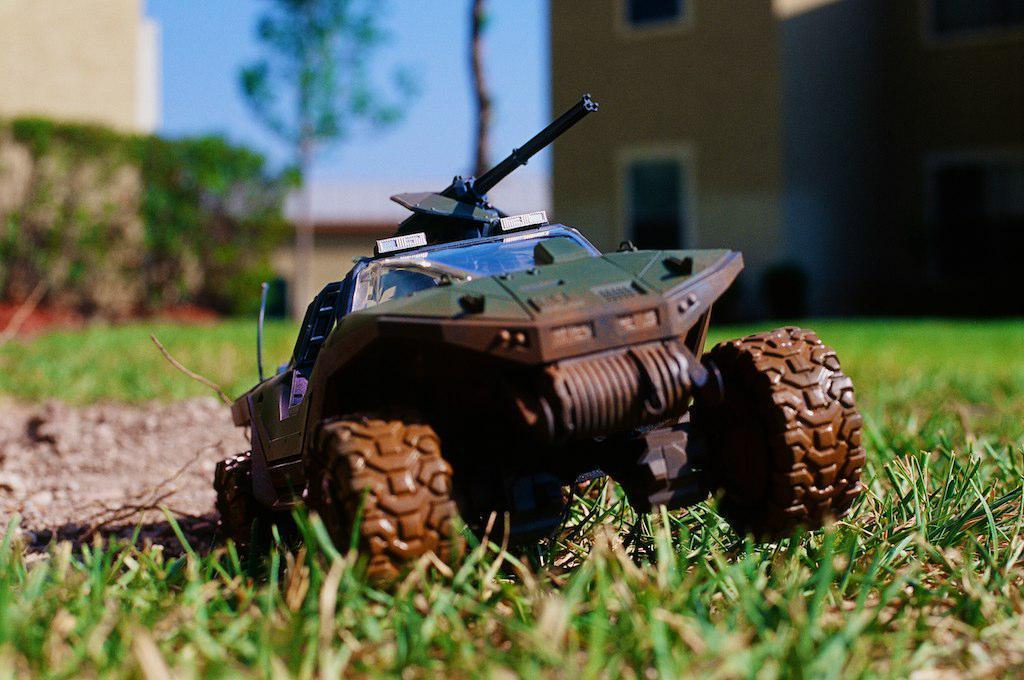Describe this image in one or two sentences. In this image we can see a toy on the ground. In the background, we can see a building with windows, a group of trees and sky. 